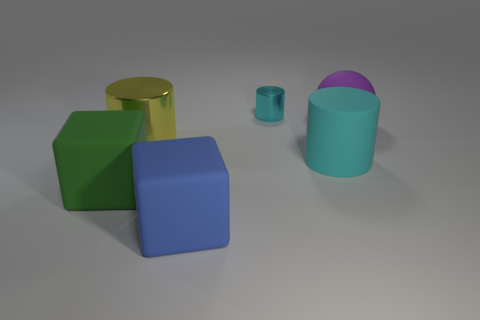Subtract all big cylinders. How many cylinders are left? 1 Add 4 tiny cyan shiny objects. How many objects exist? 10 Subtract 2 blocks. How many blocks are left? 0 Subtract all yellow cylinders. How many cylinders are left? 2 Subtract all balls. How many objects are left? 5 Subtract 0 purple cubes. How many objects are left? 6 Subtract all blue cylinders. Subtract all red cubes. How many cylinders are left? 3 Subtract all yellow cylinders. How many yellow blocks are left? 0 Subtract all big yellow shiny objects. Subtract all large cyan rubber things. How many objects are left? 4 Add 4 large spheres. How many large spheres are left? 5 